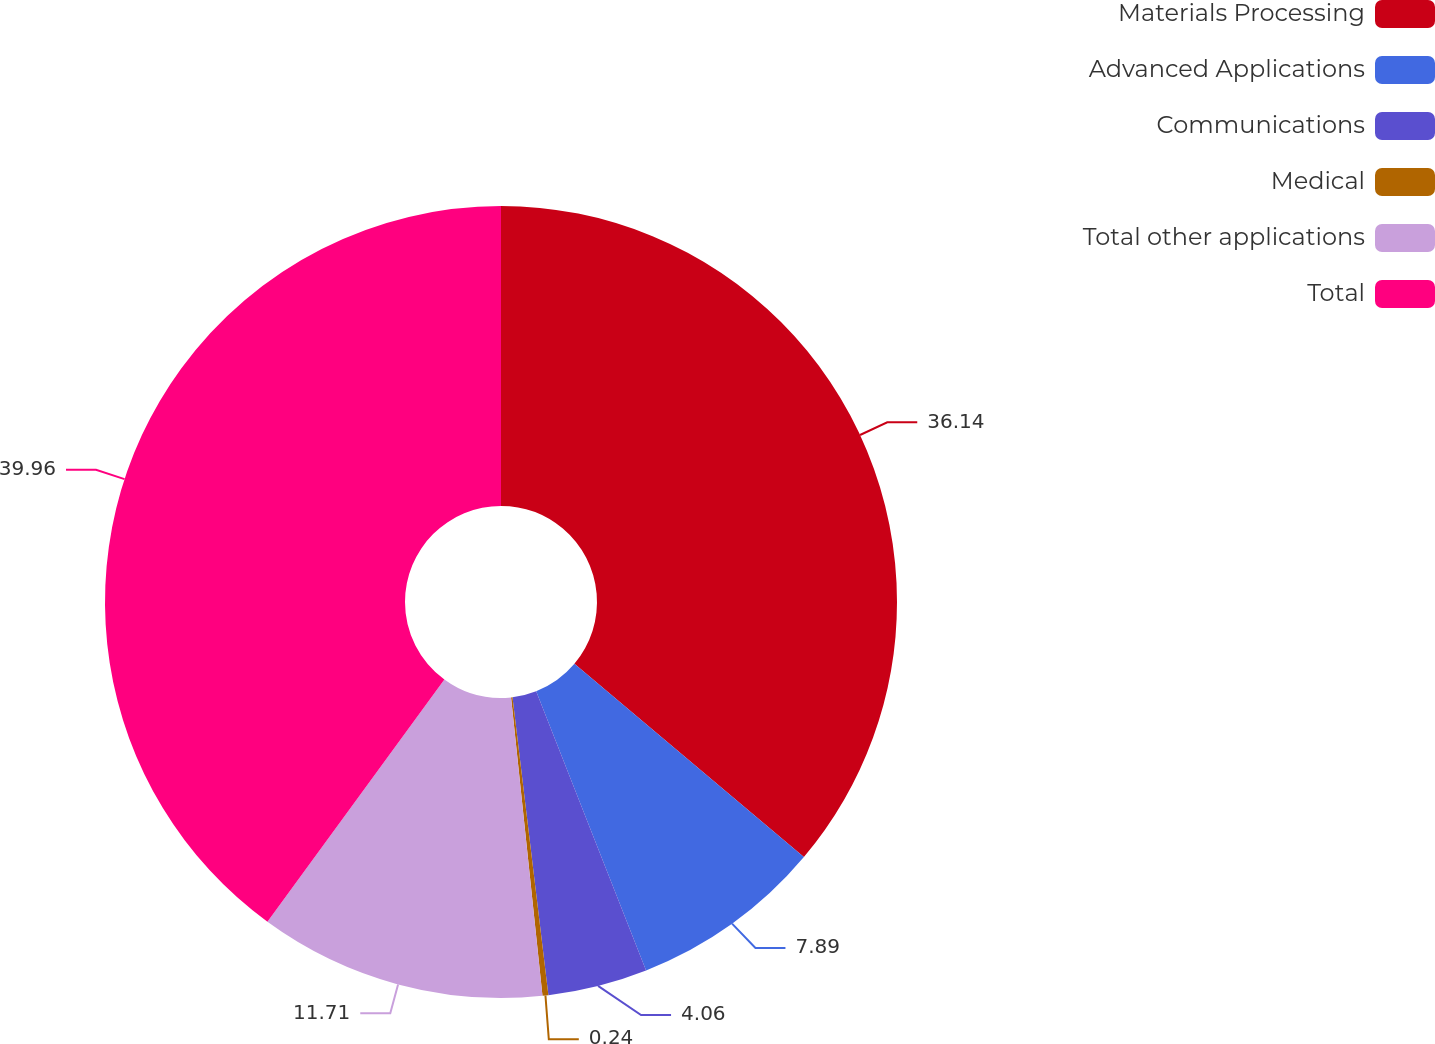<chart> <loc_0><loc_0><loc_500><loc_500><pie_chart><fcel>Materials Processing<fcel>Advanced Applications<fcel>Communications<fcel>Medical<fcel>Total other applications<fcel>Total<nl><fcel>36.14%<fcel>7.89%<fcel>4.06%<fcel>0.24%<fcel>11.71%<fcel>39.96%<nl></chart> 